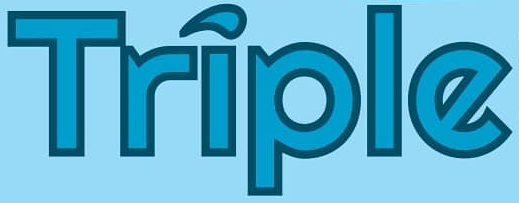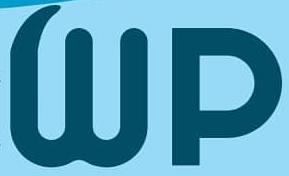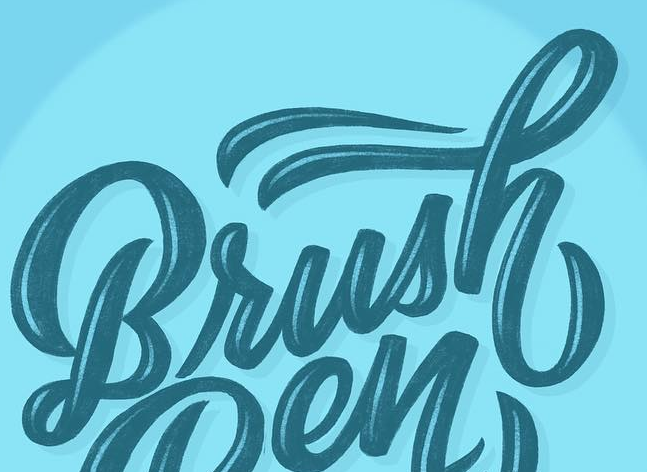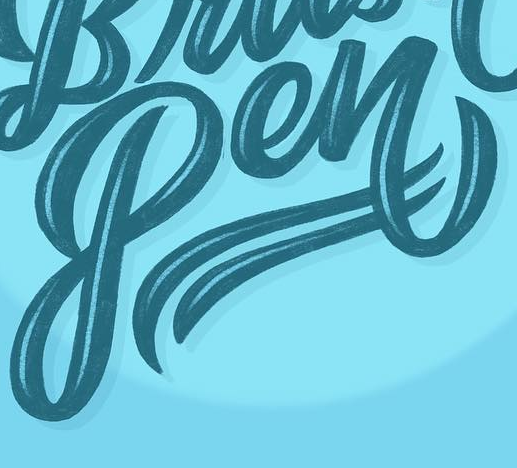Read the text content from these images in order, separated by a semicolon. Triple; Wp; Brush; Pen 